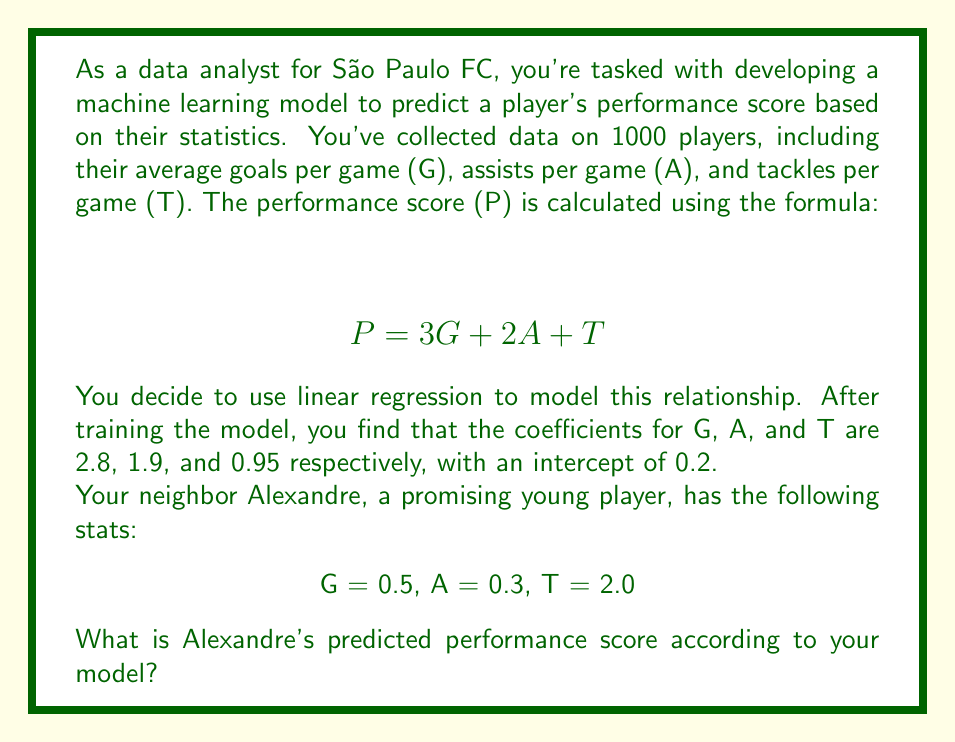Could you help me with this problem? To solve this problem, we'll follow these steps:

1) Recall the general form of a linear regression model:
   $$ y = \beta_0 + \beta_1x_1 + \beta_2x_2 + ... + \beta_nx_n $$
   where $\beta_0$ is the intercept and $\beta_1, \beta_2, ..., \beta_n$ are the coefficients for each feature.

2) In our case, the model is:
   $$ P = 0.2 + 2.8G + 1.9A + 0.95T $$

3) We need to substitute Alexandre's stats into this equation:
   G = 0.5
   A = 0.3
   T = 2.0

4) Let's calculate each term:
   Intercept: 0.2
   Goals term: $2.8 * 0.5 = 1.4$
   Assists term: $1.9 * 0.3 = 0.57$
   Tackles term: $0.95 * 2.0 = 1.9$

5) Now, we sum all these terms:
   $$ P = 0.2 + 1.4 + 0.57 + 1.9 = 4.07 $$

Therefore, Alexandre's predicted performance score according to the model is 4.07.
Answer: 4.07 